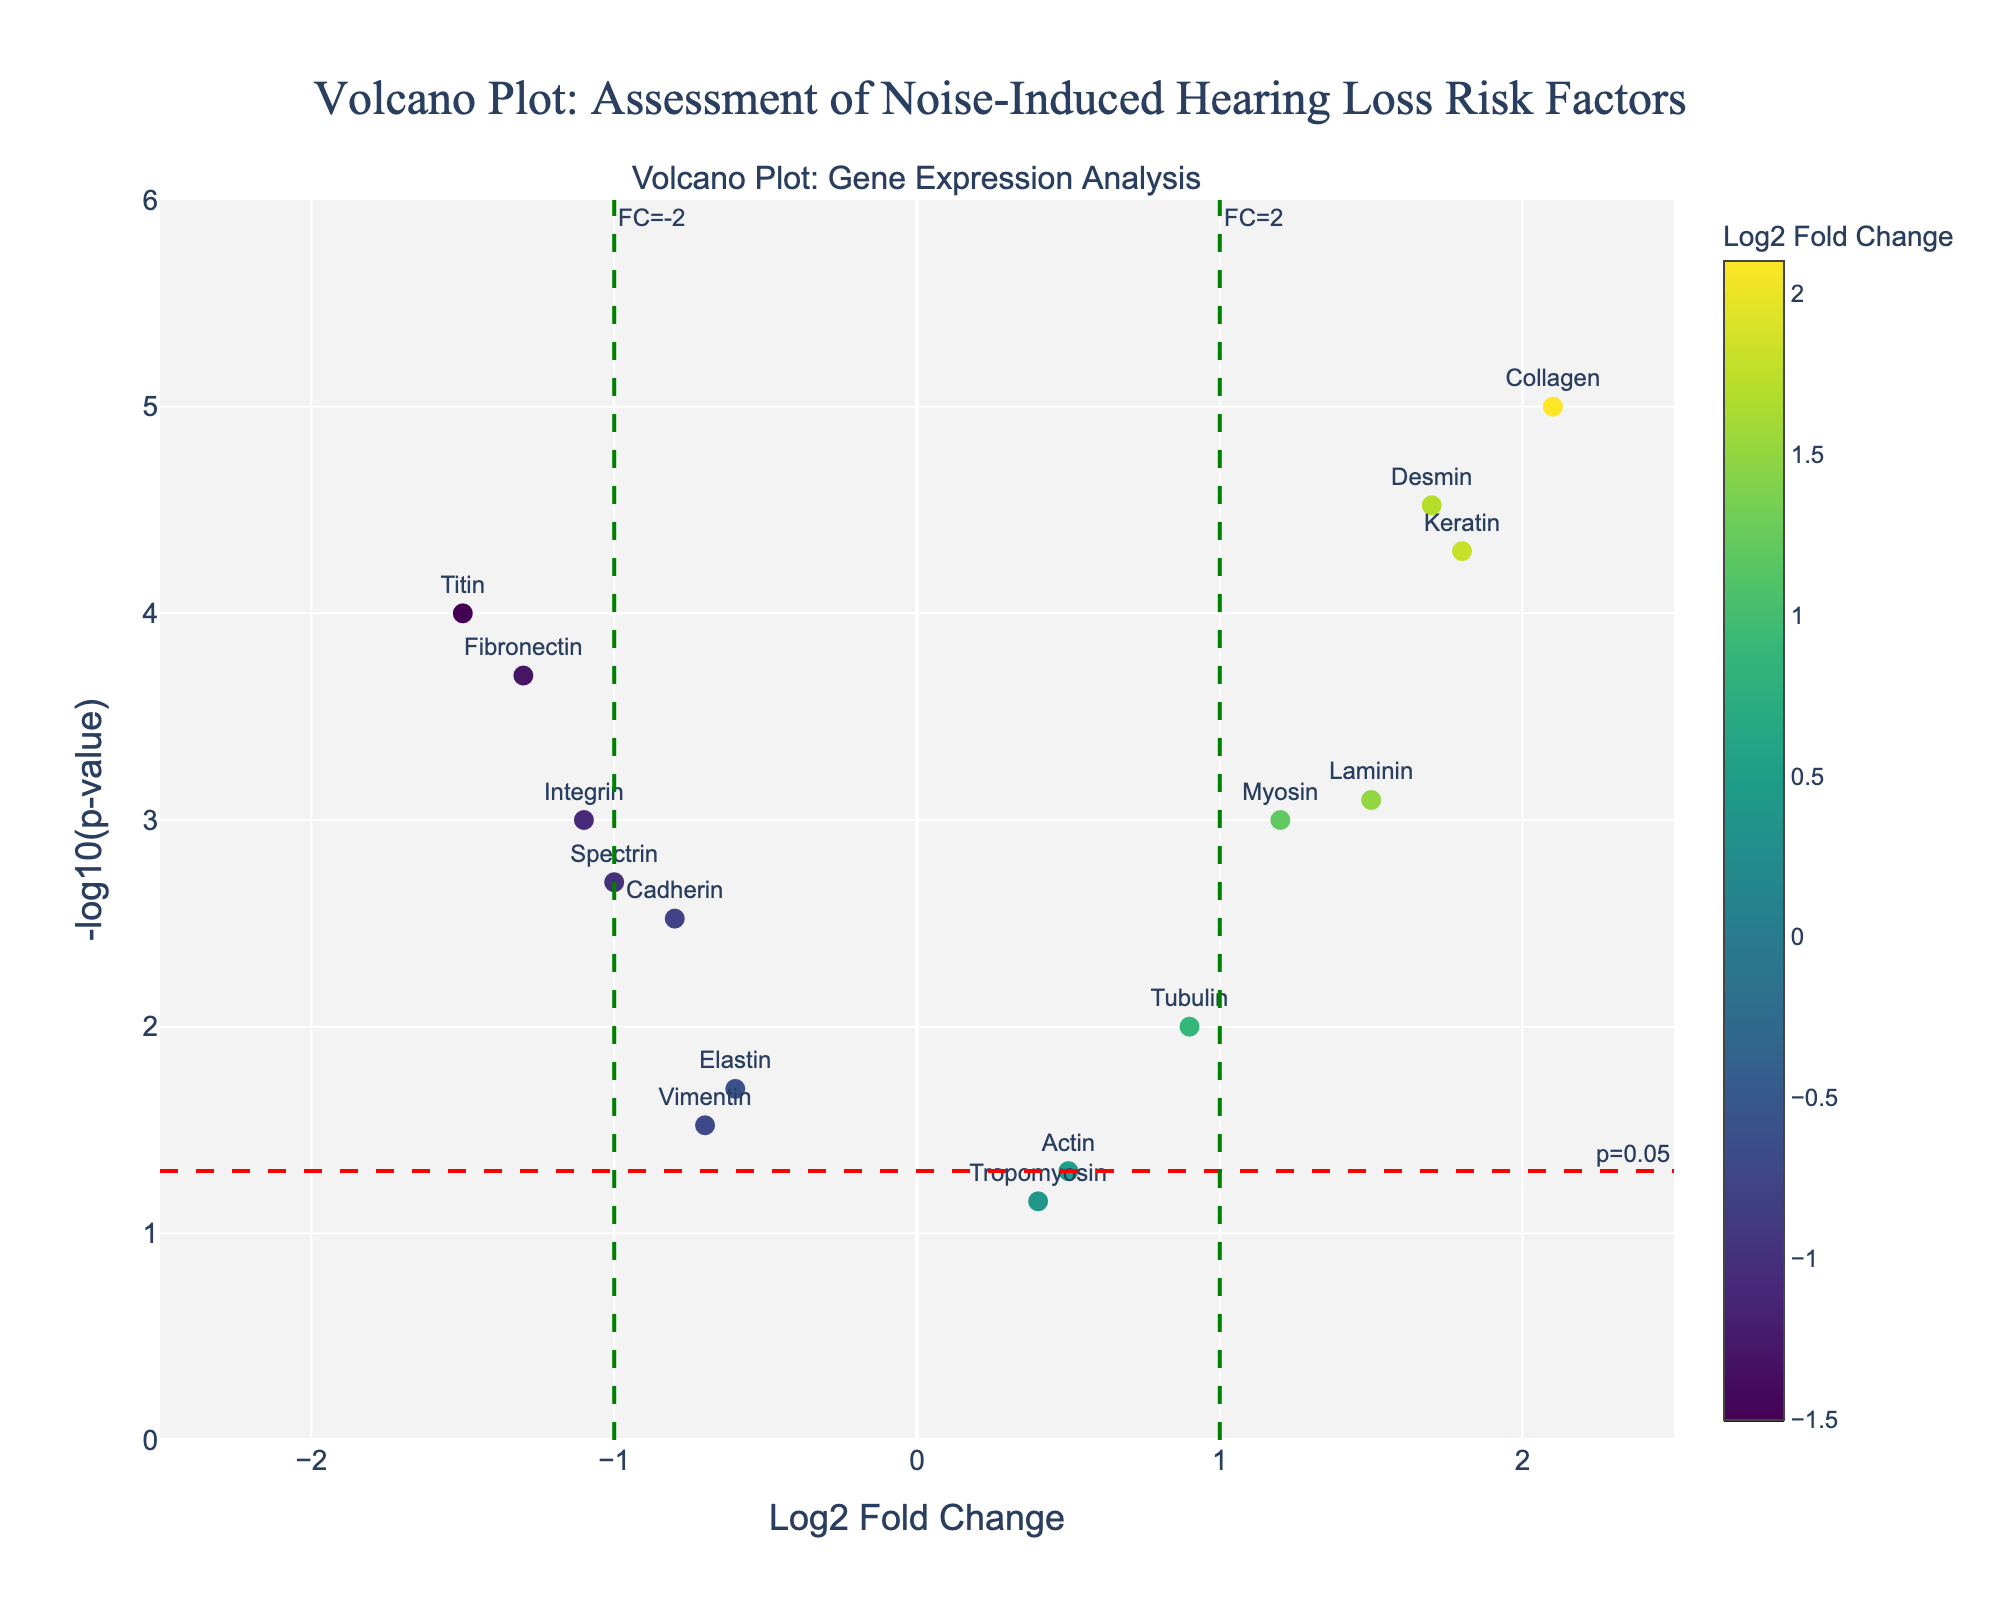what is the highest -log10(p-value) in the plot? To determine the highest -log10(p-value) in the plot, look for the point that reaches the topmost part of the y-axis. The gene "Collagen" is at the peak.
Answer: Collagen How many genes have a log2 fold change greater than 1? Identify all points located to the right of the vertical reference line marked as FC=2. The genes are Myosin, Collagen, Keratin, Laminin, and Desmin.
Answer: 5 Which gene shows the highest positive log2 fold change? Look for the point furthest to the right on the x-axis. The gene "Collagen" has a positive log2 fold change of 2.1.
Answer: Collagen How many genes have a significant p-value below 0.05? Genes with a significant p-value are above the horizontal red line marked as p=0.05. The genes are Myosin, Cadherin, Collagen, Fibronectin, Keratin, Laminin, Integrin, Desmin, Titin, and Spectrin. Count the number of such points.
Answer: 10 Which gene has the lowest log2 fold change? Look for the point furthest to the left on the x-axis. The gene "Titin" shows the lowest log2 fold change of -1.5.
Answer: Titin How many genes have both a log2 fold change less than -1 and a p-value significantly below 0.05? Identify points to the left of the vertical line at FC=-2 and above the horizontal line at p=0.05. The genes are Fibronectin, Integrin, Titin, and Spectrin.
Answer: 4 Which genes are closest to the origin (0,0) on the plot? Look for points nearest to the intersection of x=0 and y=0. The genes "Actin" and "Tropomyosin" are closest to the origin.
Answer: Actin, Tropomyosin What is the -log10(p-value) of the gene "Keratin"? Locate the "Keratin" gene on the plot and identify its y-coordinate. The -log10(p-value) is approximately 4.3.
Answer: 4.3 Which gene has the highest combined value of log2 fold change and -log10(p-value)? Calculate the combined value for each gene and identify the highest. "Keratin" has a log2 fold change of 1.8 and -log10(p-value) of 4.3, making the combined value 6.1.
Answer: Keratin Is the gene "Myosin" considered significant and upregulated based on the plot? "Myosin" is above the horizontal line at p=0.05 indicating significance, and to the right of the vertical line at FC=2 indicating upregulation.
Answer: Yes 